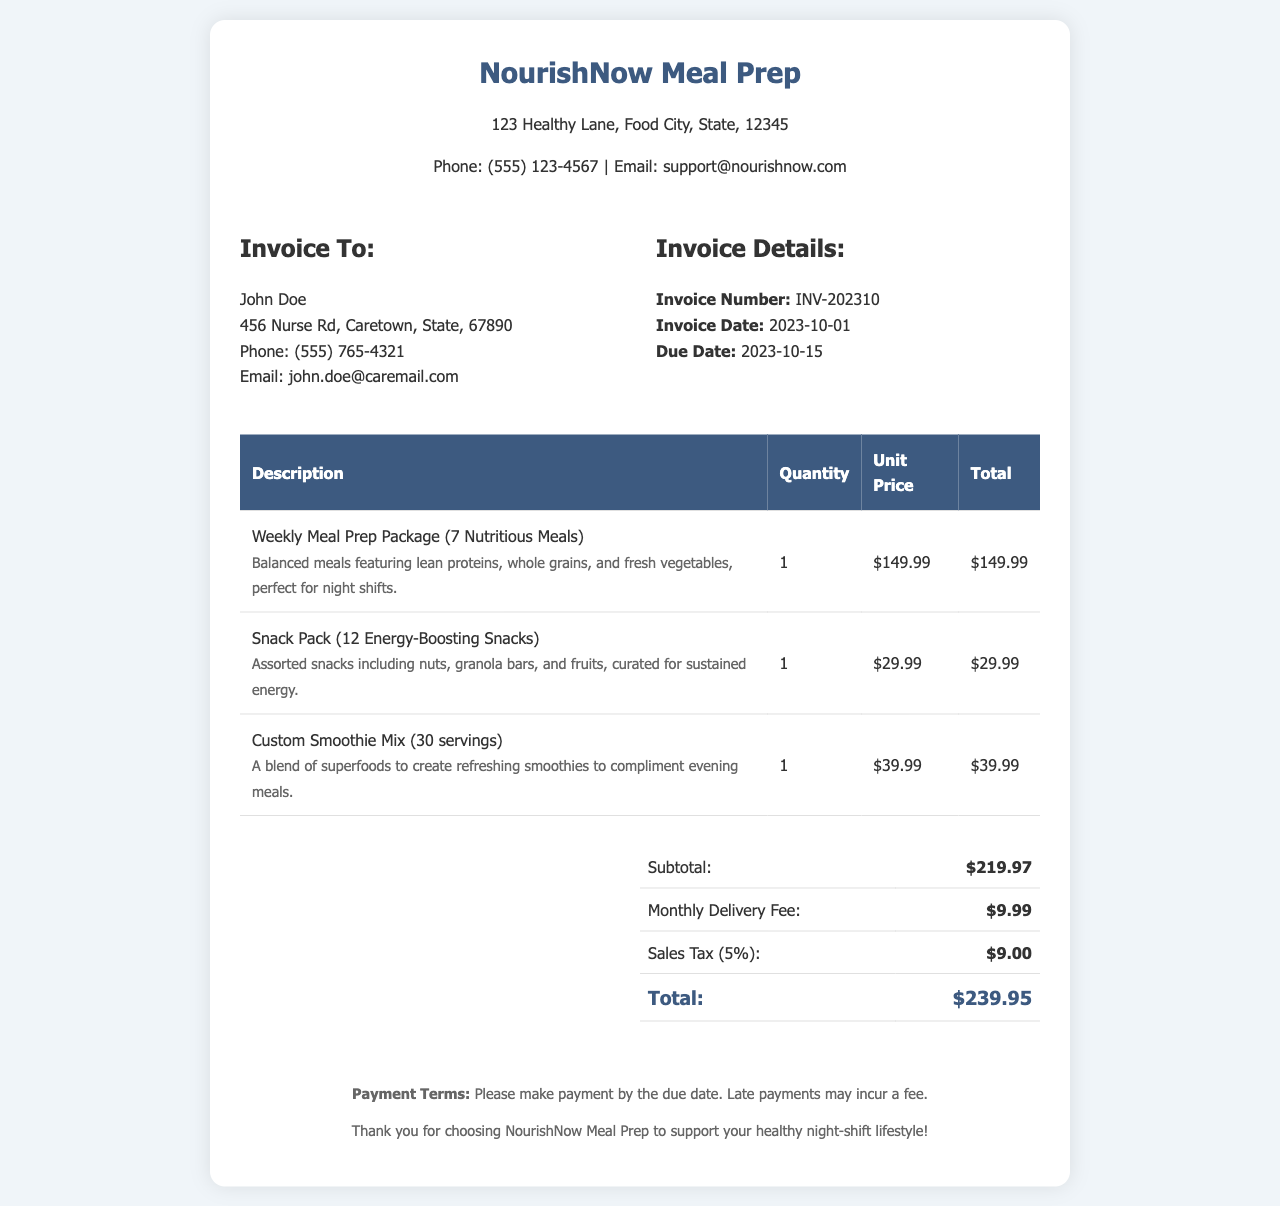What is the invoice number? The invoice number is specified in the document under the "Invoice Details" section as INV-202310.
Answer: INV-202310 Who is the invoice addressed to? The invoice is addressed to John Doe, whose details are listed under the "Invoice To" section.
Answer: John Doe What is the total amount due? The total amount due is presented in the summary table at the bottom of the document.
Answer: $239.95 What is the delivery fee? The delivery fee is mentioned in the summary section as part of the total cost breakdown.
Answer: $9.99 How many energy-boosting snacks are included in the snack pack? The snack pack description clearly states it contains 12 energy-boosting snacks.
Answer: 12 What is the subtotal before taxes and fees? The subtotal is detailed in the summary table as the sum of all items before additional costs.
Answer: $219.97 What date is the invoice due? The due date is indicated in the "Invoice Details" section, specifying when the payment should be made.
Answer: 2023-10-15 What type of meals does the meal prep package include? The meal prep package description states it includes balanced meals featuring lean proteins, whole grains, and fresh vegetables.
Answer: Balanced meals How many servings does the custom smoothie mix contain? The serving count for the custom smoothie mix is provided in the item description.
Answer: 30 servings What is the sales tax percentage applied? The sales tax percentage is mentioned in the summary table as part of the calculation for the total.
Answer: 5% 